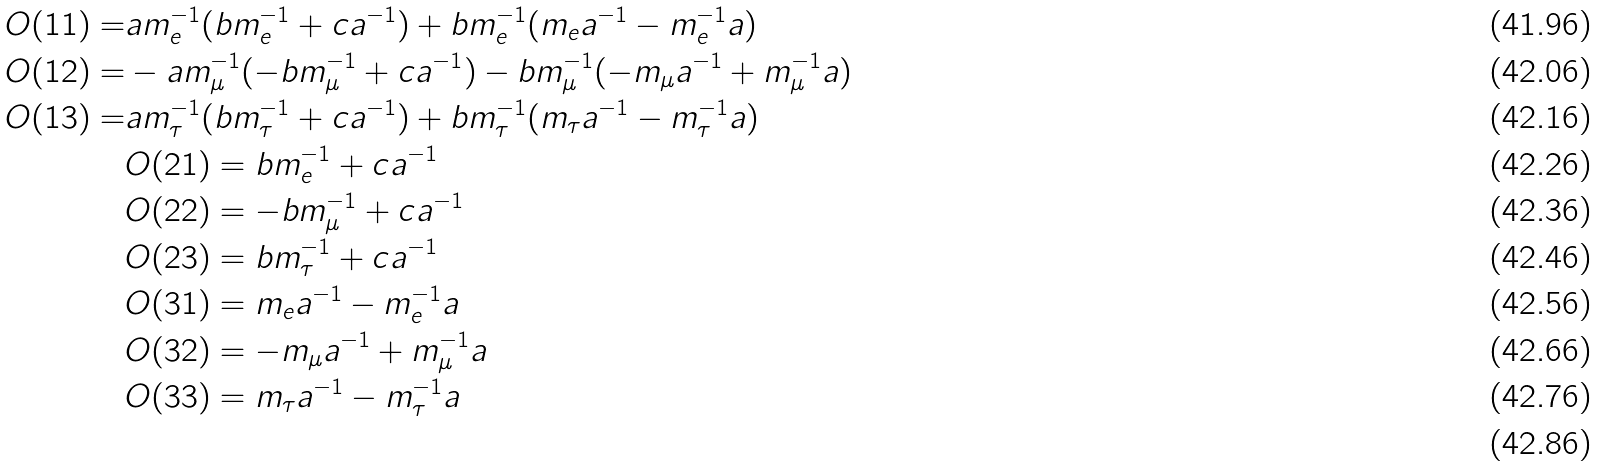Convert formula to latex. <formula><loc_0><loc_0><loc_500><loc_500>O ( 1 1 ) = & a m _ { e } ^ { - 1 } ( b m _ { e } ^ { - 1 } + c a ^ { - 1 } ) + b m _ { e } ^ { - 1 } ( m _ { e } a ^ { - 1 } - m _ { e } ^ { - 1 } a ) \\ O ( 1 2 ) = & - a m _ { \mu } ^ { - 1 } ( - b m _ { \mu } ^ { - 1 } + c a ^ { - 1 } ) - b m _ { \mu } ^ { - 1 } ( - m _ { \mu } a ^ { - 1 } + m _ { \mu } ^ { - 1 } a ) \\ O ( 1 3 ) = & a m _ { \tau } ^ { - 1 } ( b m _ { \tau } ^ { - 1 } + c a ^ { - 1 } ) + b m _ { \tau } ^ { - 1 } ( m _ { \tau } a ^ { - 1 } - m _ { \tau } ^ { - 1 } a ) \\ & O ( 2 1 ) = b m _ { e } ^ { - 1 } + c a ^ { - 1 } \\ & O ( 2 2 ) = - b m _ { \mu } ^ { - 1 } + c a ^ { - 1 } \\ & O ( 2 3 ) = b m _ { \tau } ^ { - 1 } + c a ^ { - 1 } \\ & O ( 3 1 ) = m _ { e } a ^ { - 1 } - m _ { e } ^ { - 1 } a \\ & O ( 3 2 ) = - m _ { \mu } a ^ { - 1 } + m _ { \mu } ^ { - 1 } a \\ & O ( 3 3 ) = m _ { \tau } a ^ { - 1 } - m _ { \tau } ^ { - 1 } a \\</formula> 